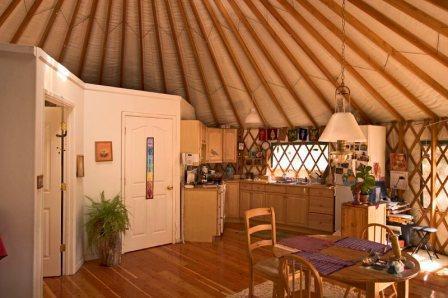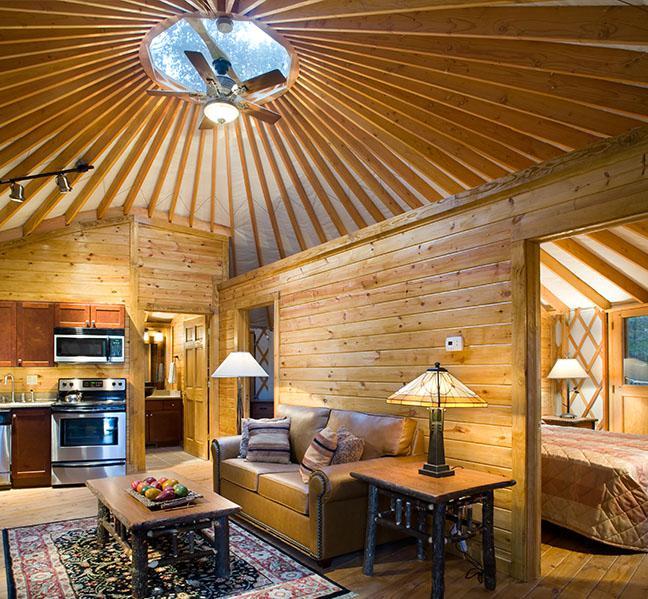The first image is the image on the left, the second image is the image on the right. For the images shown, is this caption "At least one room has a patterned oriental-type rug on the floor." true? Answer yes or no. Yes. 